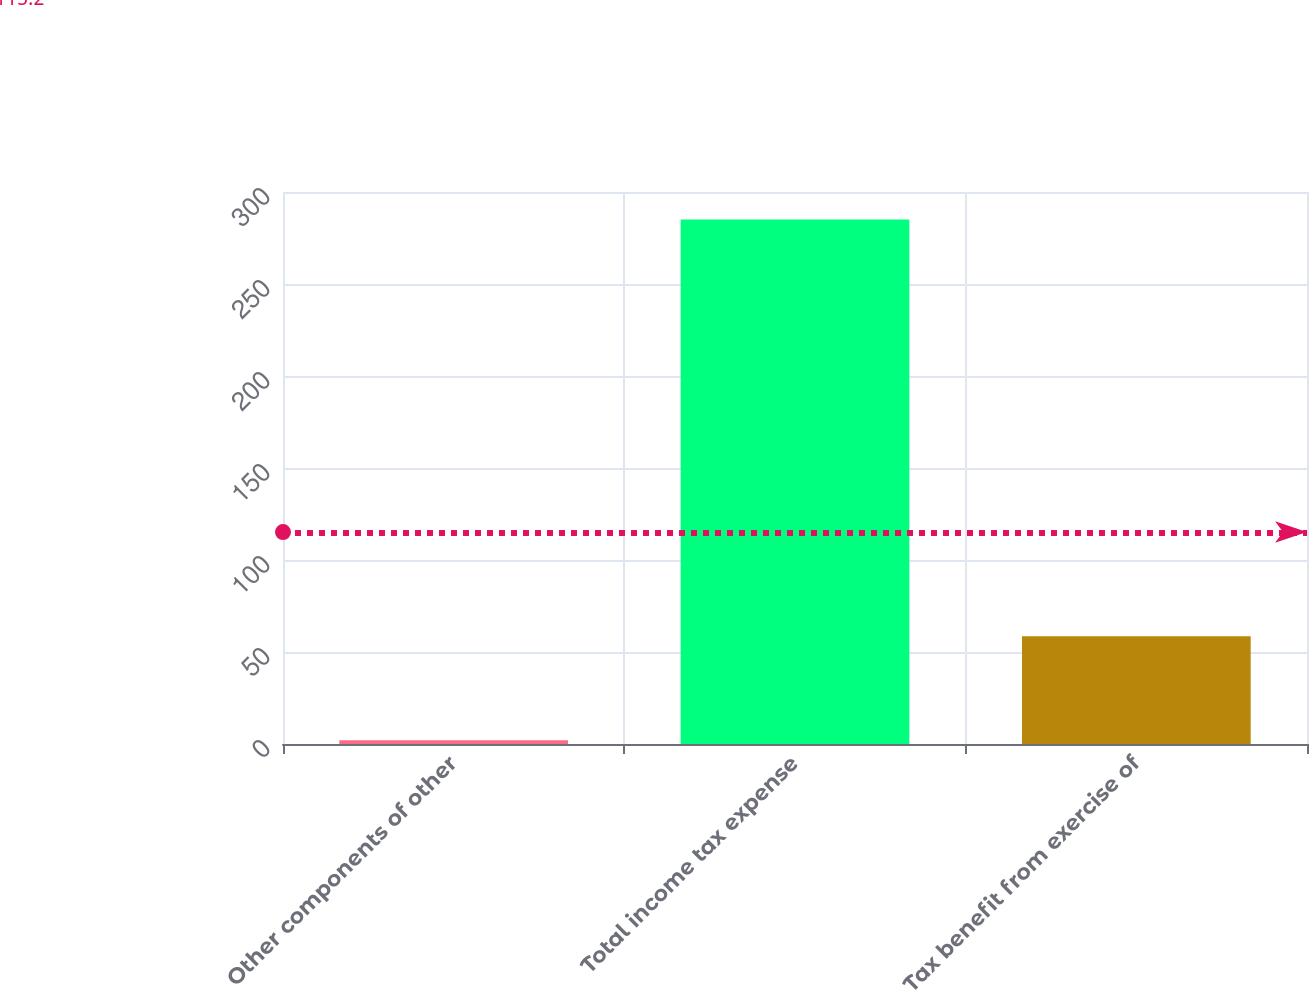Convert chart. <chart><loc_0><loc_0><loc_500><loc_500><bar_chart><fcel>Other components of other<fcel>Total income tax expense<fcel>Tax benefit from exercise of<nl><fcel>2<fcel>285<fcel>58.6<nl></chart> 